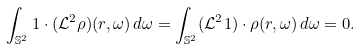<formula> <loc_0><loc_0><loc_500><loc_500>\int _ { \mathbb { S } ^ { 2 } } 1 \cdot ( { \mathcal { L } } ^ { 2 } \rho ) ( r , \omega ) \, d \omega = \int _ { \mathbb { S } ^ { 2 } } ( \mathcal { L } ^ { 2 } 1 ) \cdot \rho ( r , \omega ) \, d \omega = 0 .</formula> 